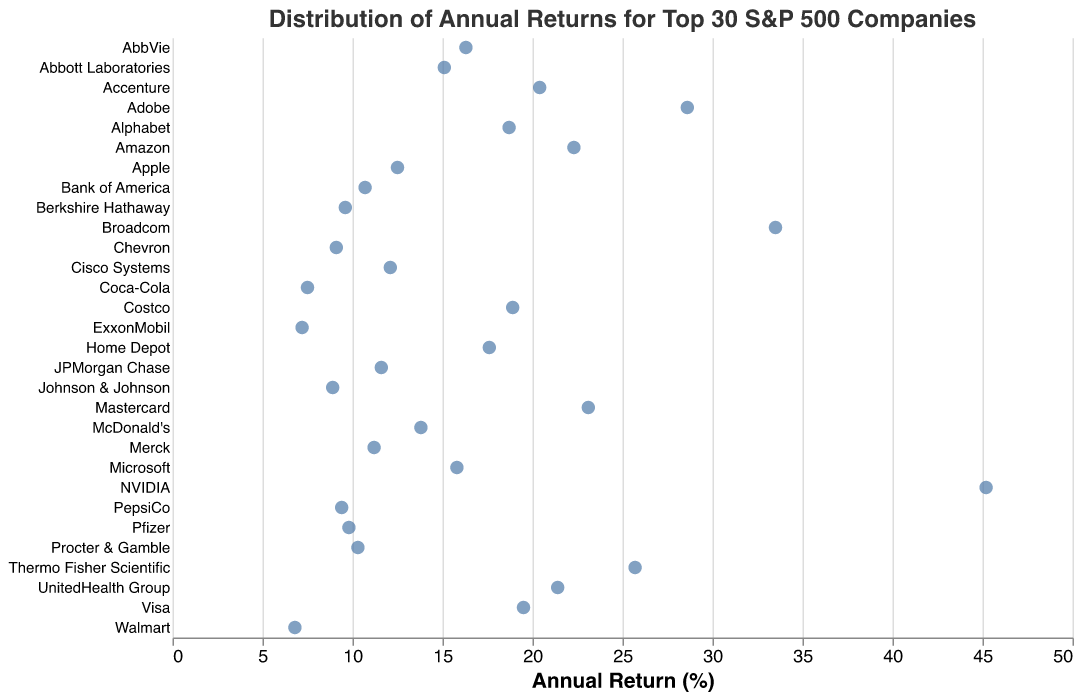What is the title of the plot? The title is typically displayed at the top of the figure and provides a summary of the data being visualized.
Answer: Distribution of Annual Returns for Top 30 S&P 500 Companies Which company has the highest annual return? To find this, look for the company positioned furthest to the right on the x-axis since the x-axis represents annual return in this layout.
Answer: NVIDIA How many companies have an annual return greater than 20%? Count the number of data points (companies) placed to the right of the '20' mark on the x-axis.
Answer: 9 Which company has the lowest annual return? Locate the company represented at the furthest left on the x-axis to identify the one with the lowest annual return.
Answer: Walmart What is the range of annual returns for the companies? The range is the difference between the maximum and minimum values on the x-axis. The maximum return is for NVIDIA (45.2%) and the minimum is for Walmart (6.8%), so calculate 45.2 - 6.8.
Answer: 38.4% Which companies have annual returns close to 10%? Identify the data points located at or near the 10% mark on the x-axis and read the corresponding company names.
Answer: Procter & Gamble, Pfizer, Bank of America, PepsiCo Compare the annual returns of Microsoft and Alphabet. Which one is higher? Locate the positions of Microsoft and Alphabet on the x-axis, then compare their x-values. Microsoft has an annual return of 15.8%, and Alphabet has 18.7%.
Answer: Alphabet What key feature identifies each data point on the strip plot? Data points are typically illustrated using points that are often filled and sized differently to stand out on the plot. The tooltip on hover highlights the company and its return.
Answer: Filled points Among companies listed, which has the closest annual return to the median value? First, identify the median (middle) value in a sorted list of returns. Sorting the companies' returns: ...9.8, 10.3 (Procter & Gamble). The closest to the middle value around 11% would be around JPMorgan Chase (11.6%) and Bank of America (10.7%).
Answer: JPMorgan Chase, Bank of America 